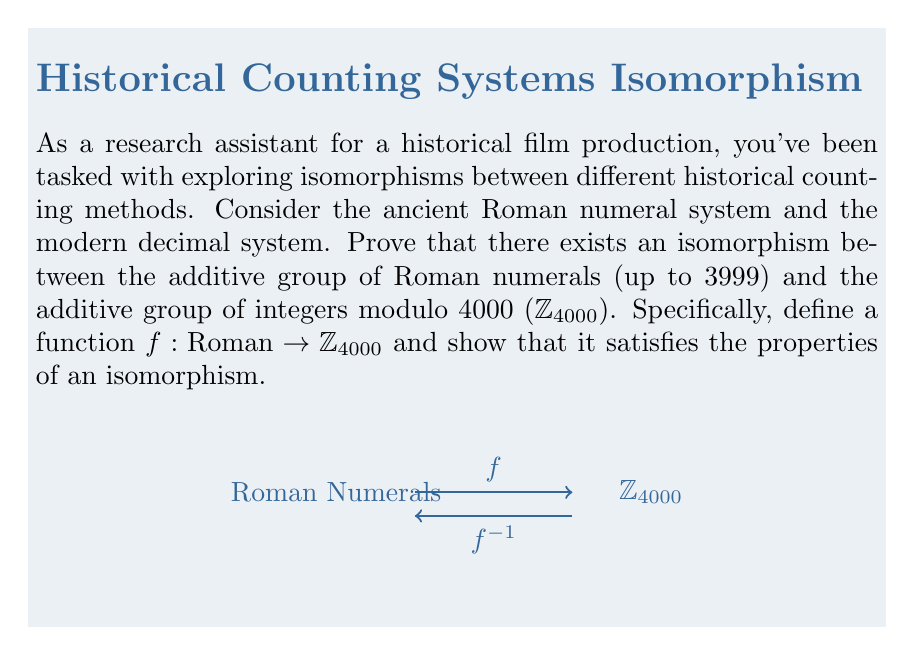Can you answer this question? To prove that there exists an isomorphism between the Roman numeral system (up to 3999) and $\mathbb{Z}_{4000}$, we need to define a function $f$ and show that it is both a homomorphism and bijective.

Step 1: Define the function $f$
Let $f: \text{Roman} \rightarrow \mathbb{Z}_{4000}$ be defined as:
$f(\text{Roman numeral}) = \text{decimal equivalent} \mod 4000$

For example:
$f(\text{I}) = 1$
$f(\text{V}) = 5$
$f(\text{X}) = 10$
$f(\text{L}) = 50$
$f(\text{C}) = 100$
$f(\text{D}) = 500$
$f(\text{M}) = 1000$

Step 2: Prove that $f$ is a homomorphism
For any two Roman numerals $a$ and $b$, we need to show that:
$f(a + b) = f(a) + f(b) \mod 4000$

This holds because the decimal equivalent of the sum of two Roman numerals is equal to the sum of their decimal equivalents. The modulo 4000 operation preserves this property.

Step 3: Prove that $f$ is injective (one-to-one)
If $f(a) = f(b)$, then $a$ and $b$ must represent the same number in the Roman system. This is because each Roman numeral has a unique decimal equivalent (up to 3999).

Step 4: Prove that $f$ is surjective (onto)
For every element $k \in \mathbb{Z}_{4000}$, there exists a Roman numeral $r$ such that $f(r) = k$. This is because every integer from 0 to 3999 has a corresponding Roman numeral representation.

Step 5: Conclusion
Since $f$ is both injective and surjective, it is bijective. Combined with the fact that it is a homomorphism, we can conclude that $f$ is an isomorphism between the Roman numeral system (up to 3999) and $\mathbb{Z}_{4000}$.

The inverse function $f^{-1}: \mathbb{Z}_{4000} \rightarrow \text{Roman}$ can be defined as:
$f^{-1}(k) = \text{Roman numeral equivalent of } k \text{ (if } k < 4000 \text{) or } k - 4000 \text{ (if } k \geq 4000\text{)}$
Answer: $f(\text{Roman numeral}) = \text{decimal equivalent} \mod 4000$ 